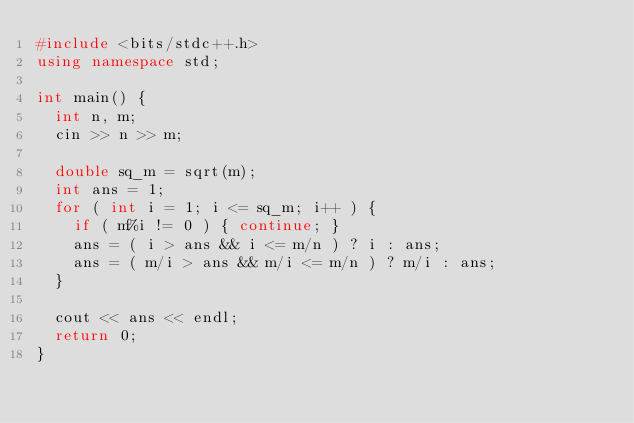<code> <loc_0><loc_0><loc_500><loc_500><_C++_>#include <bits/stdc++.h>
using namespace std;

int main() {
  int n, m;
  cin >> n >> m;

  double sq_m = sqrt(m);
  int ans = 1;
  for ( int i = 1; i <= sq_m; i++ ) {
    if ( m%i != 0 ) { continue; }
    ans = ( i > ans && i <= m/n ) ? i : ans;
    ans = ( m/i > ans && m/i <= m/n ) ? m/i : ans;
  }

  cout << ans << endl;
  return 0;
}
</code> 